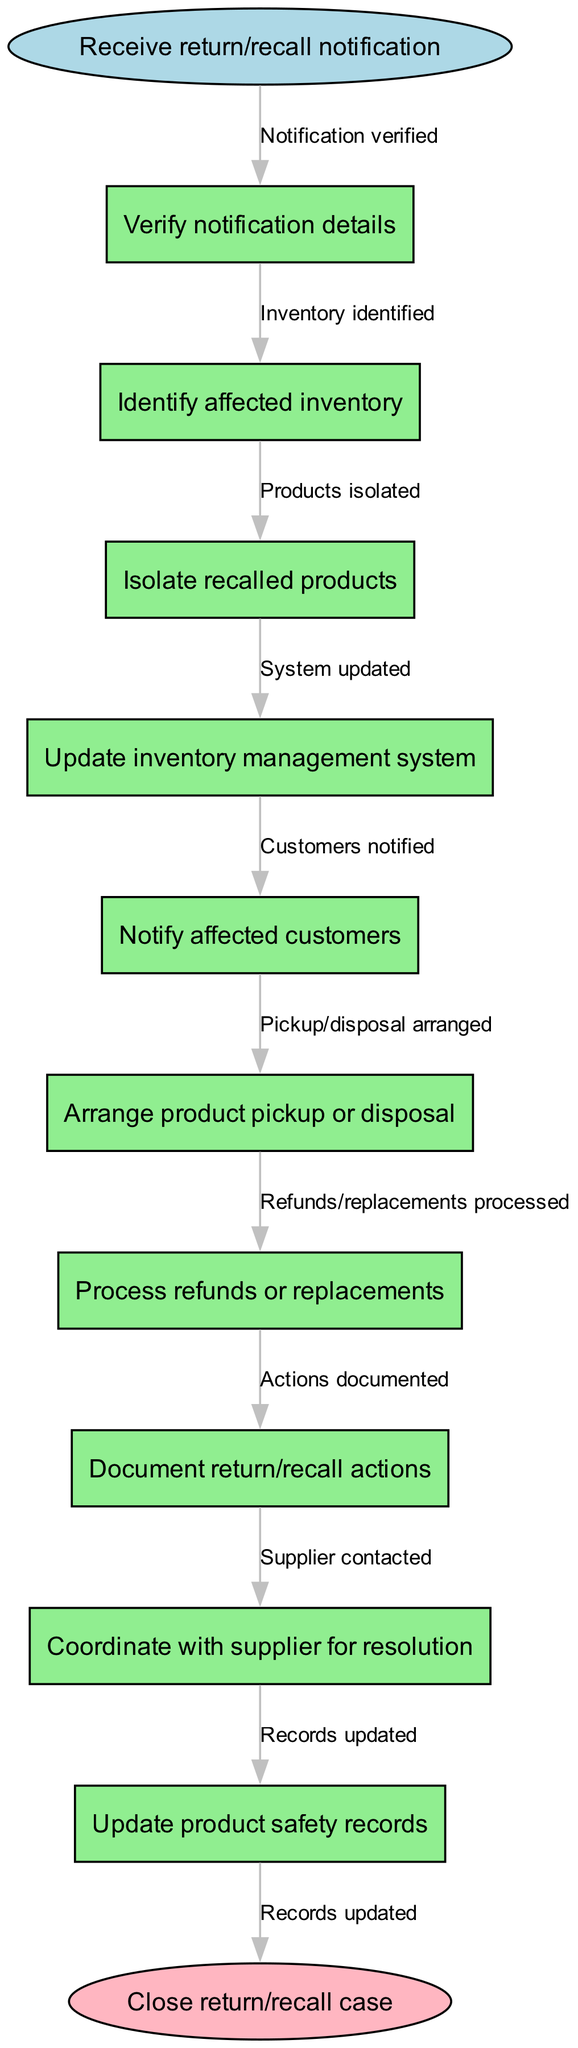What's the initial step in the clinical pathway? The initial step is labeled "Receive return/recall notification." This is the starting point of the process and is represented by the start node in the diagram.
Answer: Receive return/recall notification How many nodes are there in total? There is a total of ten nodes in the diagram: one start node, eight process nodes, and one end node. This counts all the steps involved in the clinical pathway.
Answer: 10 What is the final action before closing the case? The final action before closing the case is "Update product safety records." This represents the last step that needs to be completed in the process flow.
Answer: Update product safety records Which step follows "Identify affected inventory"? The step that follows "Identify affected inventory" is "Isolate recalled products." This indicates the sequence of actions taken once the affected inventory is identified.
Answer: Isolate recalled products How many edges connect the nodes? There are nine edges connecting the nodes in the clinical pathway. Each edge represents the flow of action from one step to the next.
Answer: 9 What action follows "Notify affected customers"? The action that follows "Notify affected customers" is "Arrange product pickup or disposal." This demonstrates the process of handling the logistics after communication is made with customers.
Answer: Arrange product pickup or disposal What action is documented in the clinical pathway? The action that is documented is "Document return/recall actions." This indicates the importance of keeping a record of all actions taken during the process.
Answer: Document return/recall actions What is the decision point that involves contacting the supplier? The decision point that involves contacting the supplier is "Coordinate with supplier for resolution." This step signifies collaboration needed to resolve the recall or return issue.
Answer: Coordinate with supplier for resolution What happens after "Update inventory management system"? After "Update inventory management system," the next action is "Notify affected customers." This illustrates the flow from updating records to communicating with customers.
Answer: Notify affected customers 